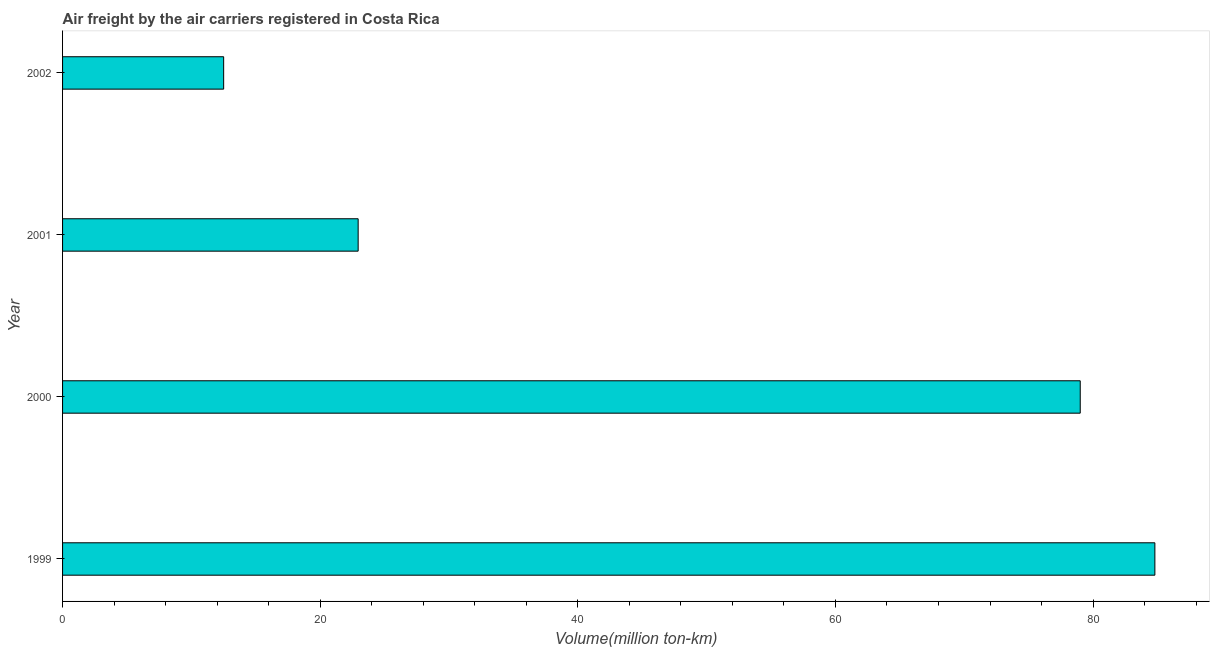Does the graph contain any zero values?
Offer a very short reply. No. Does the graph contain grids?
Your response must be concise. No. What is the title of the graph?
Provide a short and direct response. Air freight by the air carriers registered in Costa Rica. What is the label or title of the X-axis?
Give a very brief answer. Volume(million ton-km). What is the label or title of the Y-axis?
Provide a succinct answer. Year. What is the air freight in 1999?
Offer a very short reply. 84.8. Across all years, what is the maximum air freight?
Make the answer very short. 84.8. Across all years, what is the minimum air freight?
Provide a succinct answer. 12.51. What is the sum of the air freight?
Provide a short and direct response. 199.26. What is the difference between the air freight in 2000 and 2001?
Keep it short and to the point. 56.06. What is the average air freight per year?
Provide a succinct answer. 49.81. What is the median air freight?
Ensure brevity in your answer.  50.98. In how many years, is the air freight greater than 48 million ton-km?
Your response must be concise. 2. What is the ratio of the air freight in 2001 to that in 2002?
Your answer should be compact. 1.83. Is the difference between the air freight in 2001 and 2002 greater than the difference between any two years?
Your answer should be compact. No. What is the difference between the highest and the second highest air freight?
Your response must be concise. 5.79. What is the difference between the highest and the lowest air freight?
Give a very brief answer. 72.29. How many years are there in the graph?
Provide a short and direct response. 4. What is the Volume(million ton-km) in 1999?
Make the answer very short. 84.8. What is the Volume(million ton-km) of 2000?
Offer a terse response. 79. What is the Volume(million ton-km) in 2001?
Make the answer very short. 22.95. What is the Volume(million ton-km) of 2002?
Provide a short and direct response. 12.51. What is the difference between the Volume(million ton-km) in 1999 and 2000?
Make the answer very short. 5.79. What is the difference between the Volume(million ton-km) in 1999 and 2001?
Ensure brevity in your answer.  61.85. What is the difference between the Volume(million ton-km) in 1999 and 2002?
Your answer should be very brief. 72.29. What is the difference between the Volume(million ton-km) in 2000 and 2001?
Ensure brevity in your answer.  56.06. What is the difference between the Volume(million ton-km) in 2000 and 2002?
Offer a terse response. 66.5. What is the difference between the Volume(million ton-km) in 2001 and 2002?
Provide a succinct answer. 10.44. What is the ratio of the Volume(million ton-km) in 1999 to that in 2000?
Provide a short and direct response. 1.07. What is the ratio of the Volume(million ton-km) in 1999 to that in 2001?
Keep it short and to the point. 3.69. What is the ratio of the Volume(million ton-km) in 1999 to that in 2002?
Provide a short and direct response. 6.78. What is the ratio of the Volume(million ton-km) in 2000 to that in 2001?
Ensure brevity in your answer.  3.44. What is the ratio of the Volume(million ton-km) in 2000 to that in 2002?
Provide a short and direct response. 6.32. What is the ratio of the Volume(million ton-km) in 2001 to that in 2002?
Ensure brevity in your answer.  1.83. 